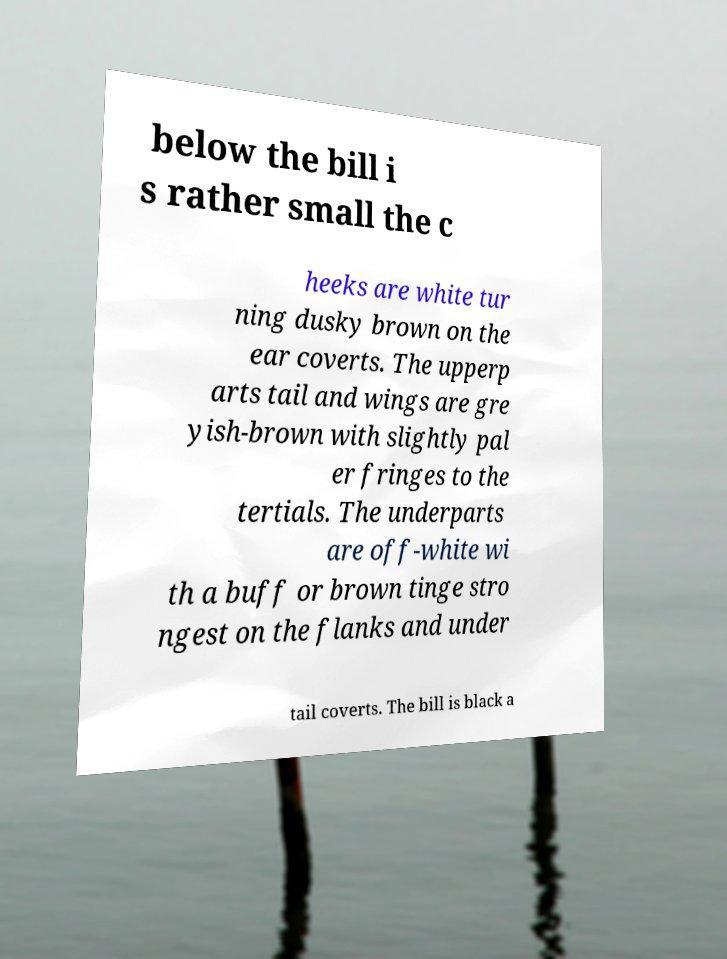What messages or text are displayed in this image? I need them in a readable, typed format. below the bill i s rather small the c heeks are white tur ning dusky brown on the ear coverts. The upperp arts tail and wings are gre yish-brown with slightly pal er fringes to the tertials. The underparts are off-white wi th a buff or brown tinge stro ngest on the flanks and under tail coverts. The bill is black a 